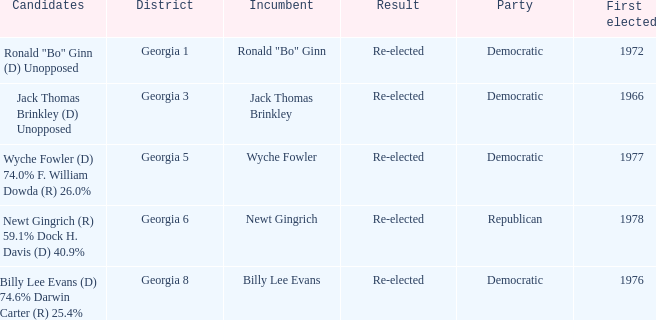What is the earliest first elected for district georgia 1? 1972.0. 